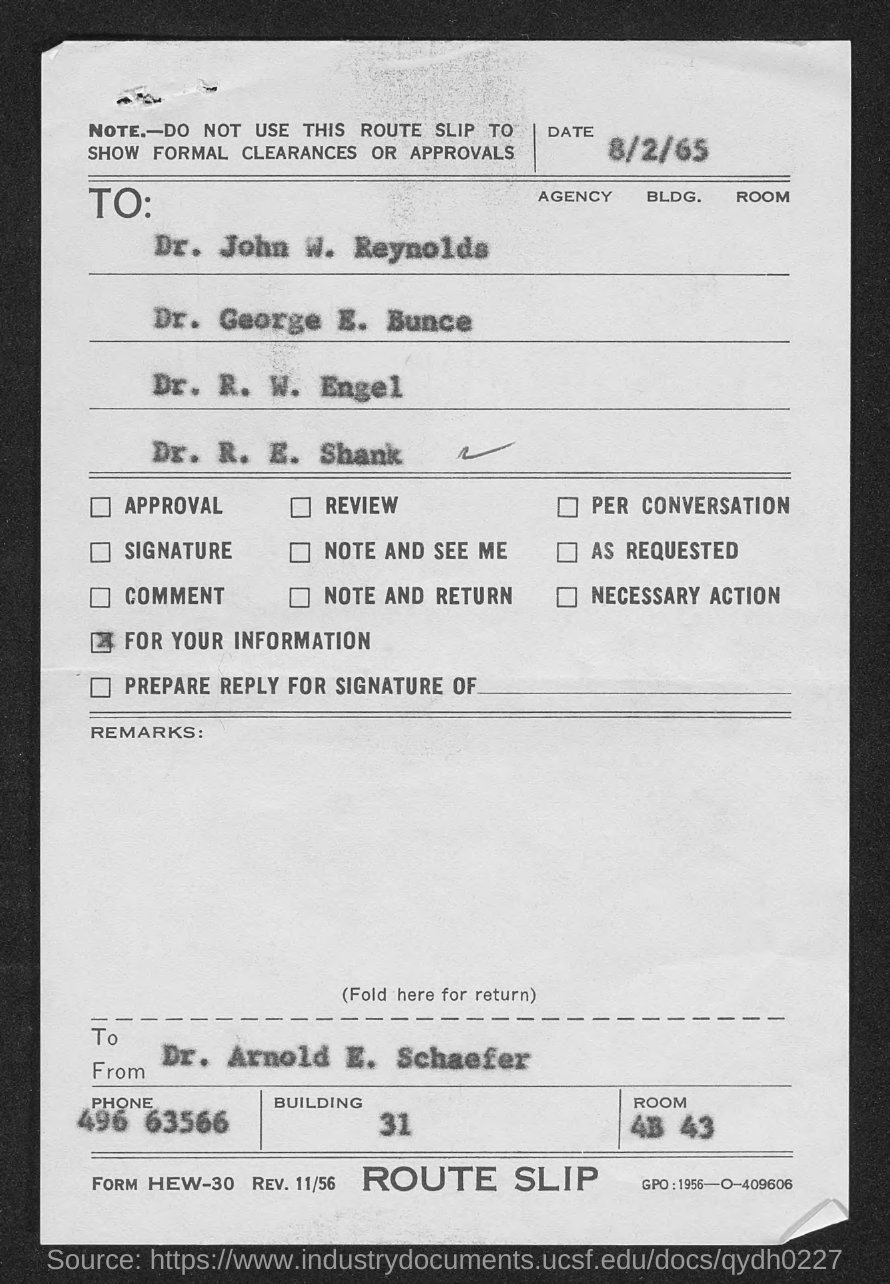Highlight a few significant elements in this photo. The document contains a date of August 2nd, 1965. The sender of this document is Dr. Arnold E. Schaefer. The room number of Dr. Arnold E. Schaefer, as listed in the document, is 4B 43. The phone number of Dr. Arnold E. Schaefer is 496-63566. 